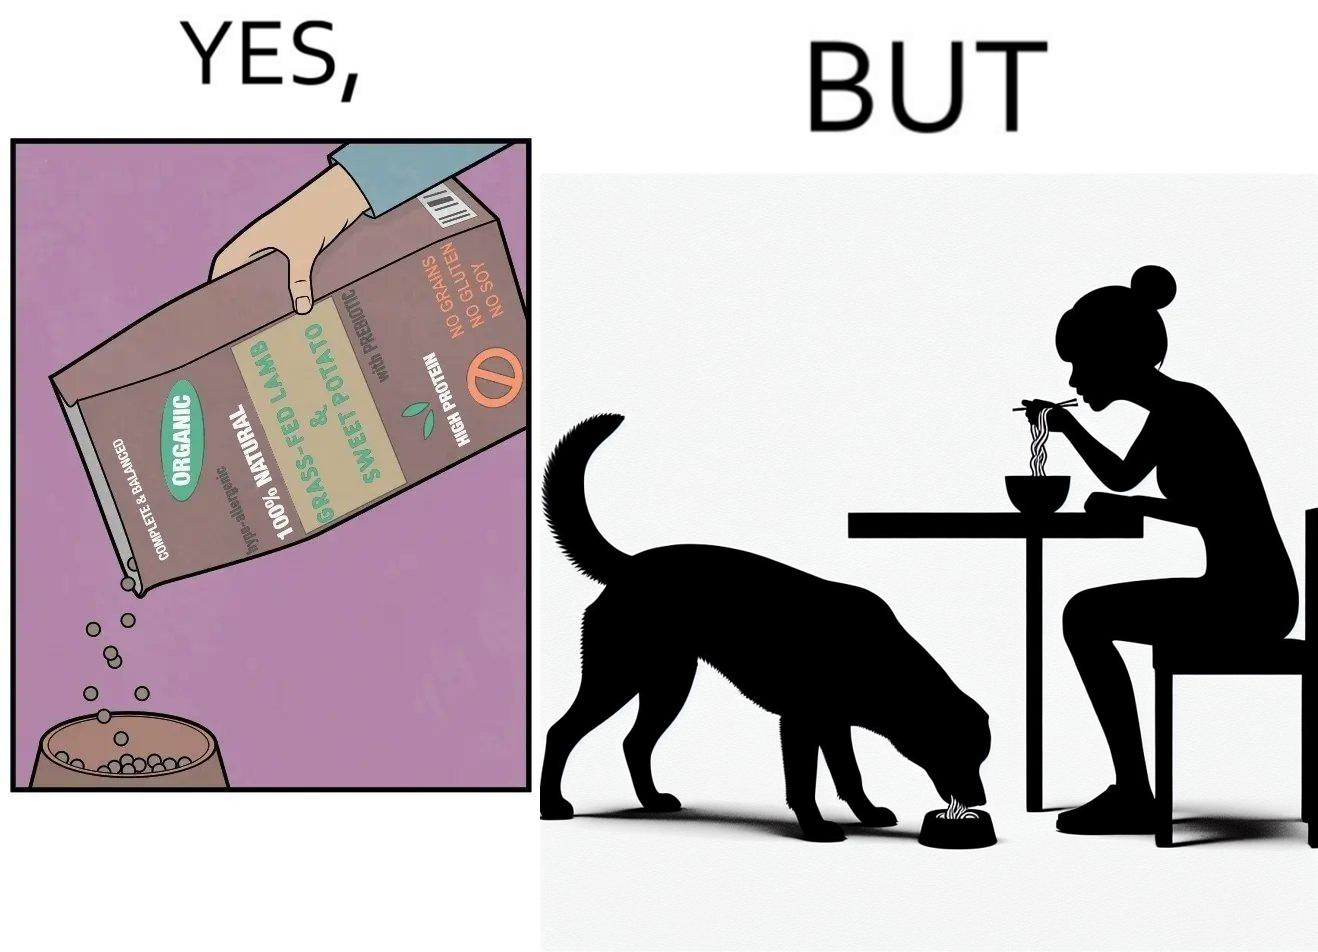Describe the content of this image. The image is funny because while the food for the dog that the woman pours is well balanced, the food that she herself is eating is bad for her health. 